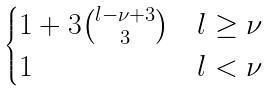Convert formula to latex. <formula><loc_0><loc_0><loc_500><loc_500>\begin{cases} 1 + 3 \binom { l - \nu + 3 } { 3 } & l \geq \nu \\ 1 & l < \nu \end{cases}</formula> 